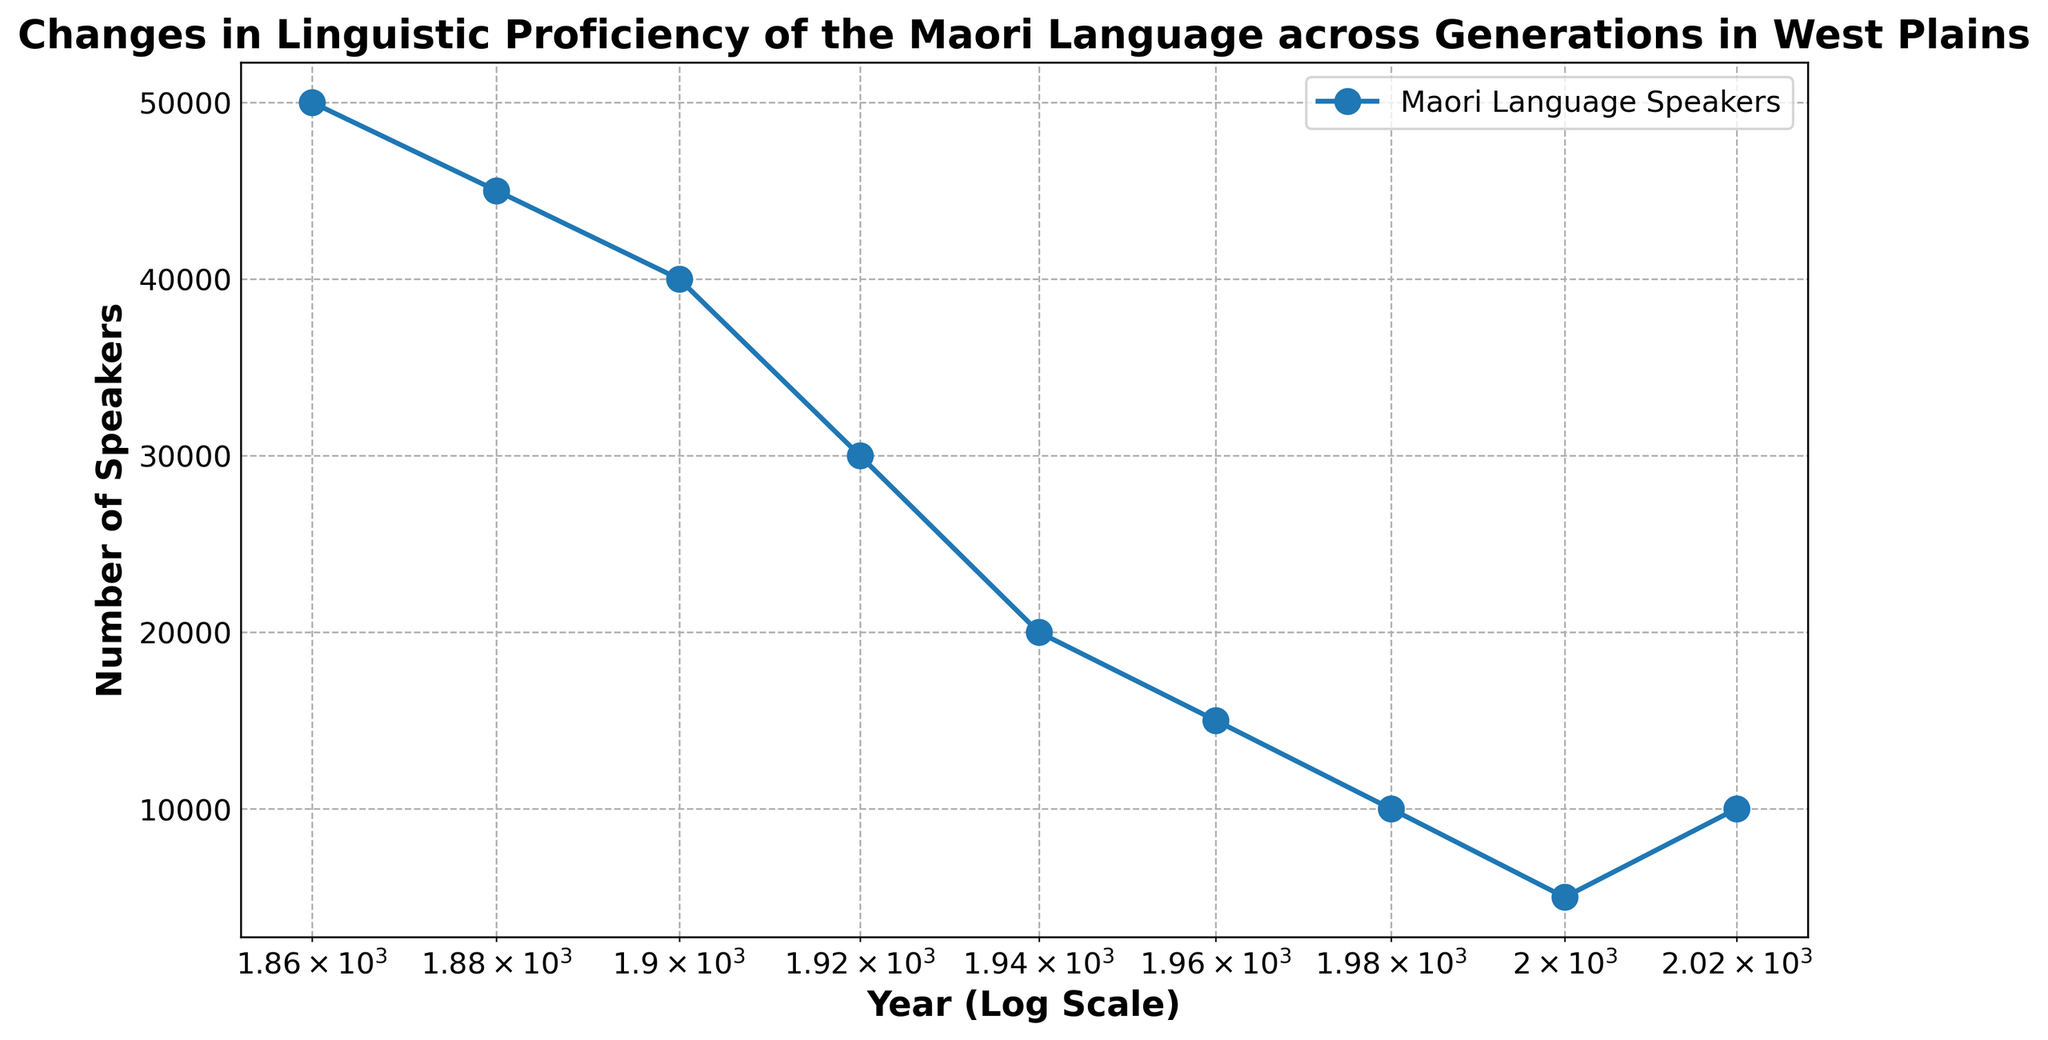What is the trend in the number of Maori language speakers from 1860 to 1980? The graph shows a declining trend in the number of Maori language speakers from 1860 (50,000) to 1980 (10,000). By joining these data points, the decline becomes apparent.
Answer: Declining What is the percentage decrease in the number of Maori language speakers from 1860 to 1940? To calculate the percentage decrease: 
1. Initial value (1860) = 50,000 
2. Final value (1940) = 20,000
3. Decrease = 50,000 - 20,000 = 30,000
4. Percentage decrease = (30,000 / 50,000) * 100 = 60%
Answer: 60% Between which two time periods did the number of Maori language speakers decrease the most? Observing the largest vertical drop between two adjacent years on the graph, the most significant decline happened between 1880 (45,000) and 1920 (30,000), with a decrease of 15,000 speakers.
Answer: 1880-1920 How does the number of Maori language speakers in 2020 compare to that in 2000? Examining the graph, the number of speakers in 2020 (10,000) is higher than that in 2000 (5,000).
Answer: Higher in 2020 What visual features indicate a change in the number of Maori language speakers between 2000 and 2020? The plot shows an upward slope from 2000 (5,000) to 2020 (10,000), using markers and the plotted line that rises during these years.
Answer: Upward slope Calculate the average yearly number of Maori language speakers for the period 1960 to 2000. Sum the numbers from 1960 (15,000), 1980 (10,000), and 2000 (5,000) and divide by 3:
1. Sum = 15,000 + 10,000 + 5,000 = 30,000
2. Average = 30,000 / 3 = 10,000
Answer: 10,000 What does the legend in the graph indicate? The legend indicates the plotted line represents "Maori Language Speakers" across different years.
Answer: Maori Language Speakers How many generations show a positive trend in the number of Maori language speakers? Only the generation from 2000 to 2020 shows a positive trend with an increase in the number of speakers.
Answer: One generation 